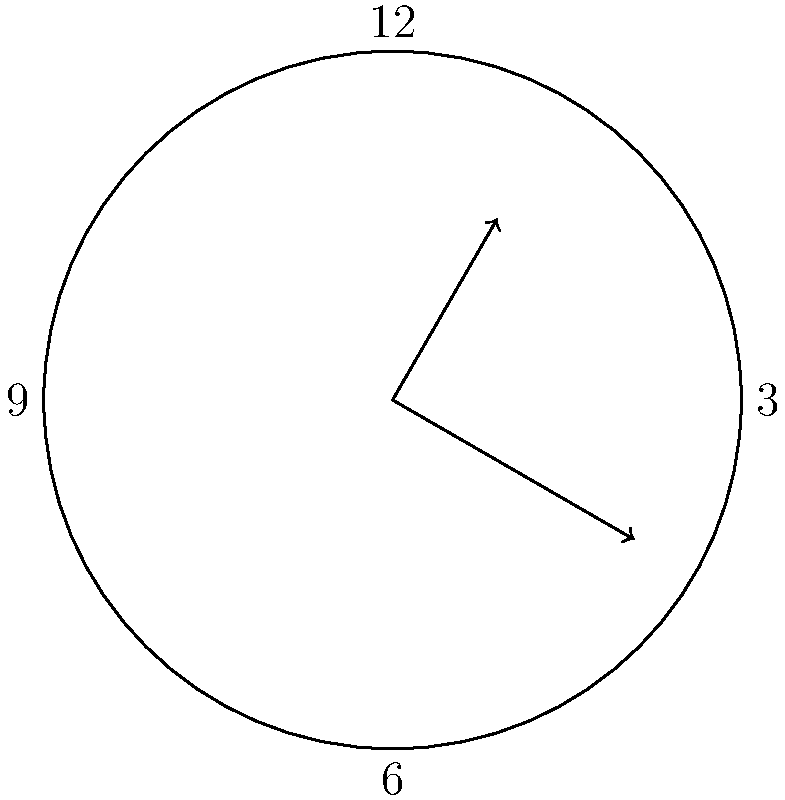In an antique clock, the hour hand and minute hand form an angle at a specific time. If the clock shows 2:55, what is the acute angle formed between the hour and minute hands? To solve this problem, we need to follow these steps:

1) First, let's calculate the angle moved by each hand:

   - Hour hand: In 12 hours, it rotates 360°. In 1 hour, it rotates 30°.
     At 2:55, it has moved: $2 \times 30° + (55/60) \times 30° = 60° + 27.5° = 87.5°$

   - Minute hand: In 60 minutes, it rotates 360°. In 1 minute, it rotates 6°.
     At 55 minutes, it has moved: $55 \times 6° = 330°$

2) The angle between the hands is the absolute difference between these angles:
   $|330° - 87.5°| = 242.5°$

3) However, we're asked for the acute angle. If the angle is greater than 180°, we need to subtract it from 360°:

   $360° - 242.5° = 117.5°$

Therefore, the acute angle between the hands is 117.5°.
Answer: $117.5°$ 